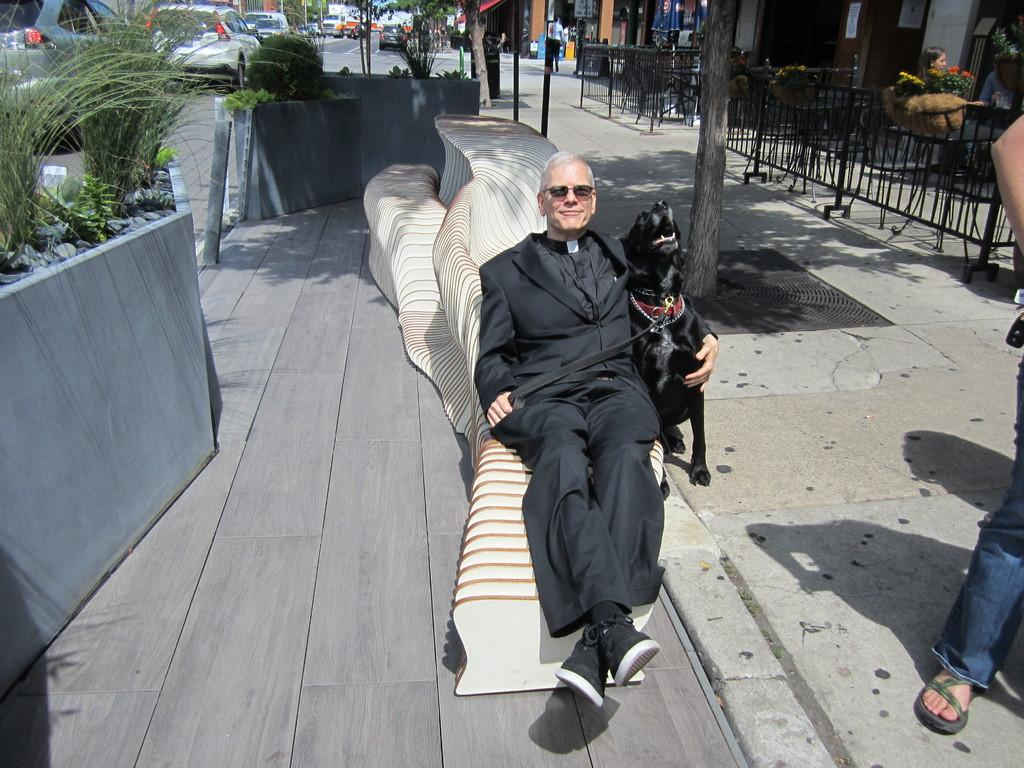What is the man in the image wearing? The man is wearing a black suit. What is the man holding in the image? The man is holding a dog. What is the man lying on in the image? The man is lying on an object in the street. What type of vegetation is present in the image? There is a plant in the image. What type of vehicles are present in the image? Cars are present in the image. What type of establishments can be seen in the image? There are shops in the image. What type of horse can be seen in the image? There is no horse present in the image. Is the man riding a bike in the image? No, the man is not riding a bike in the image; he is lying on an object in the street while holding a dog. 